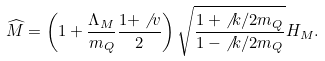<formula> <loc_0><loc_0><loc_500><loc_500>\widehat { M } = \left ( 1 + \frac { \Lambda _ { M } } { m _ { Q } } \frac { 1 + \not \, v } { 2 } \right ) \sqrt { \frac { 1 + { \not \, k } / { 2 m _ { Q } } } { 1 - { \not \, k } / { 2 m _ { Q } } } } H _ { M } .</formula> 